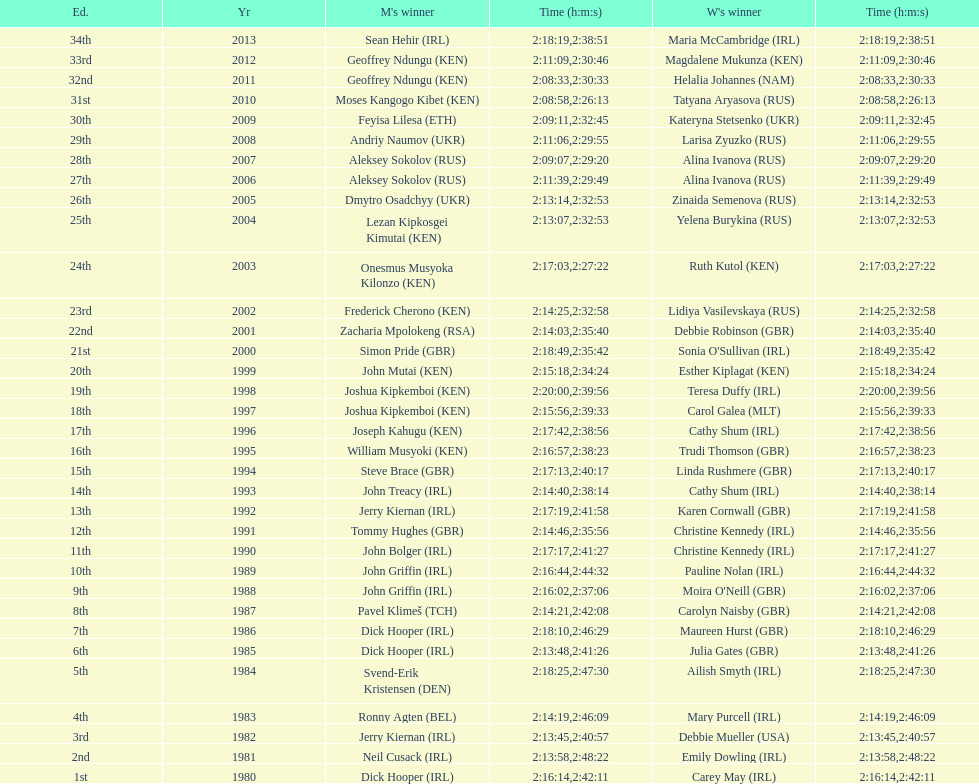Which nation is represented for both males and females at the peak of the list? Ireland. 